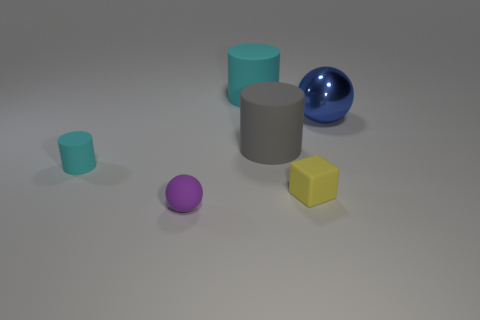Add 2 big gray rubber things. How many objects exist? 8 Subtract all purple matte balls. Subtract all tiny matte cylinders. How many objects are left? 4 Add 2 big cylinders. How many big cylinders are left? 4 Add 5 matte spheres. How many matte spheres exist? 6 Subtract 0 blue cylinders. How many objects are left? 6 Subtract all blocks. How many objects are left? 5 